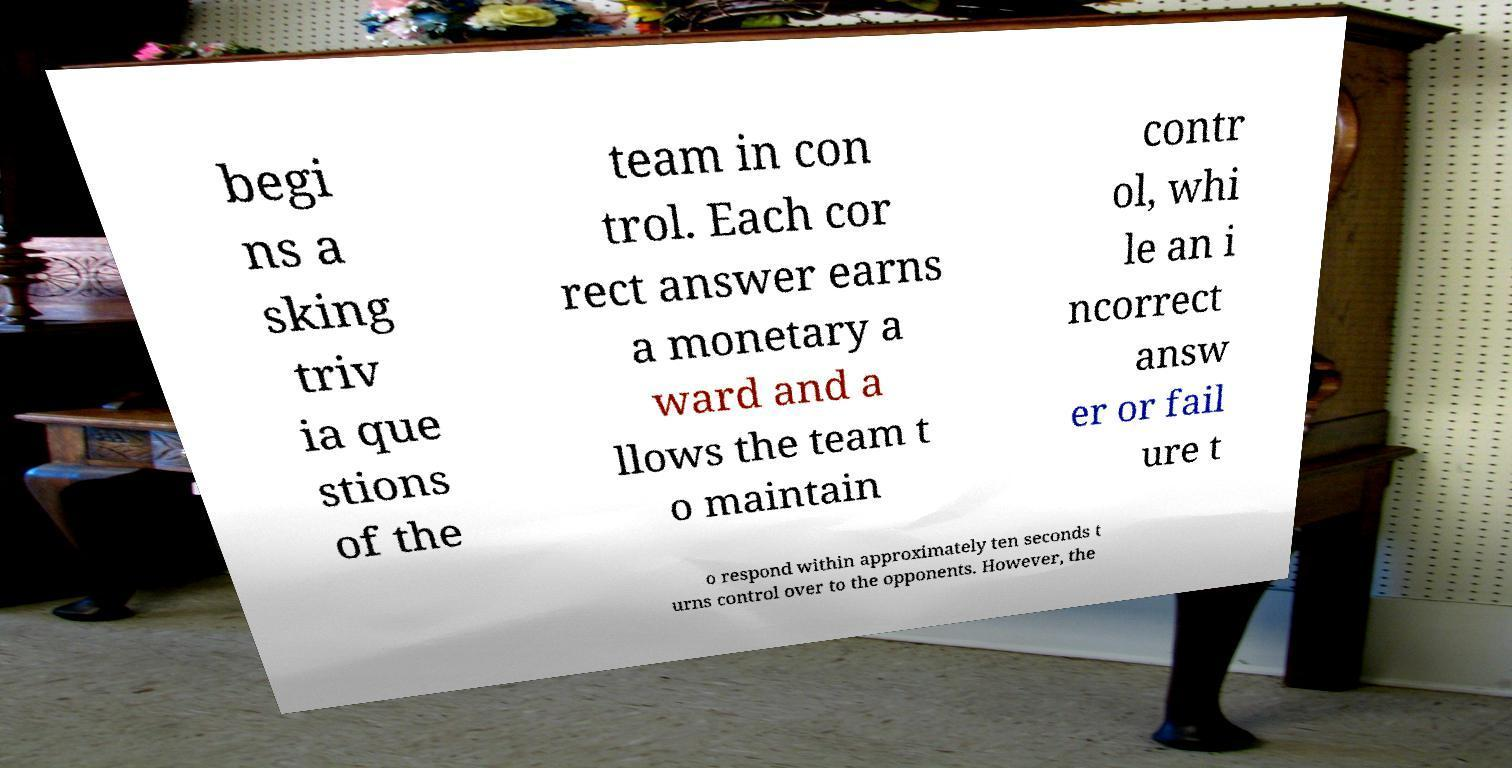Can you read and provide the text displayed in the image?This photo seems to have some interesting text. Can you extract and type it out for me? begi ns a sking triv ia que stions of the team in con trol. Each cor rect answer earns a monetary a ward and a llows the team t o maintain contr ol, whi le an i ncorrect answ er or fail ure t o respond within approximately ten seconds t urns control over to the opponents. However, the 